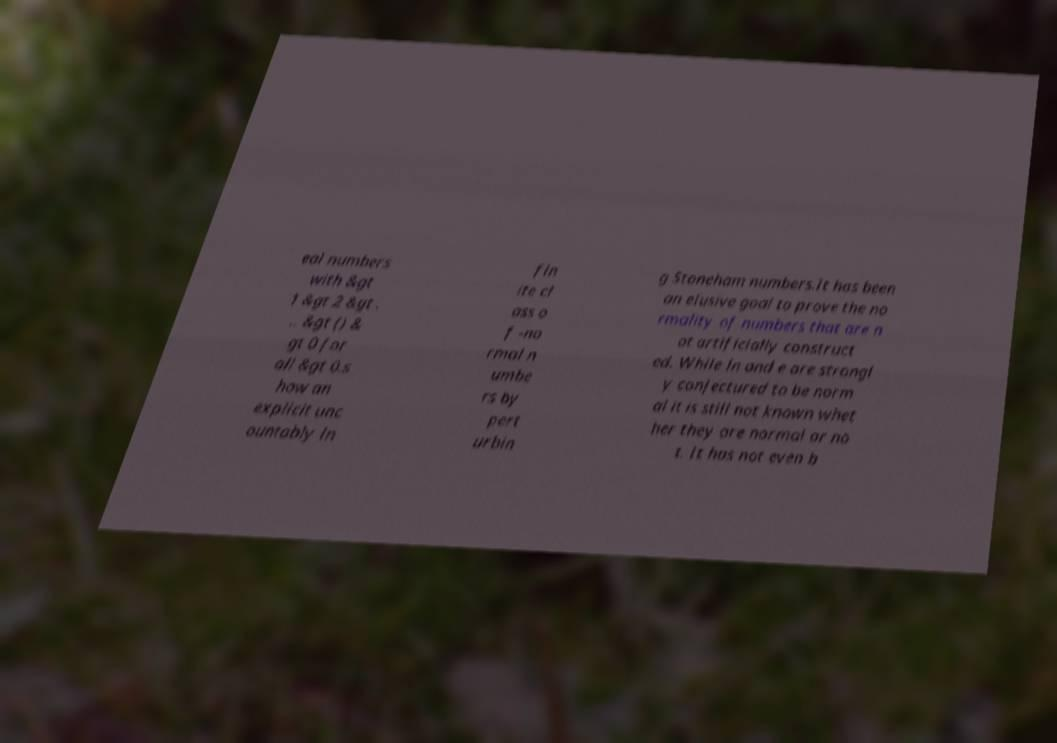What messages or text are displayed in this image? I need them in a readable, typed format. eal numbers with &gt 1 &gt 2 &gt . .. &gt () & gt 0 for all &gt 0.s how an explicit unc ountably in fin ite cl ass o f -no rmal n umbe rs by pert urbin g Stoneham numbers.It has been an elusive goal to prove the no rmality of numbers that are n ot artificially construct ed. While ln and e are strongl y conjectured to be norm al it is still not known whet her they are normal or no t. It has not even b 